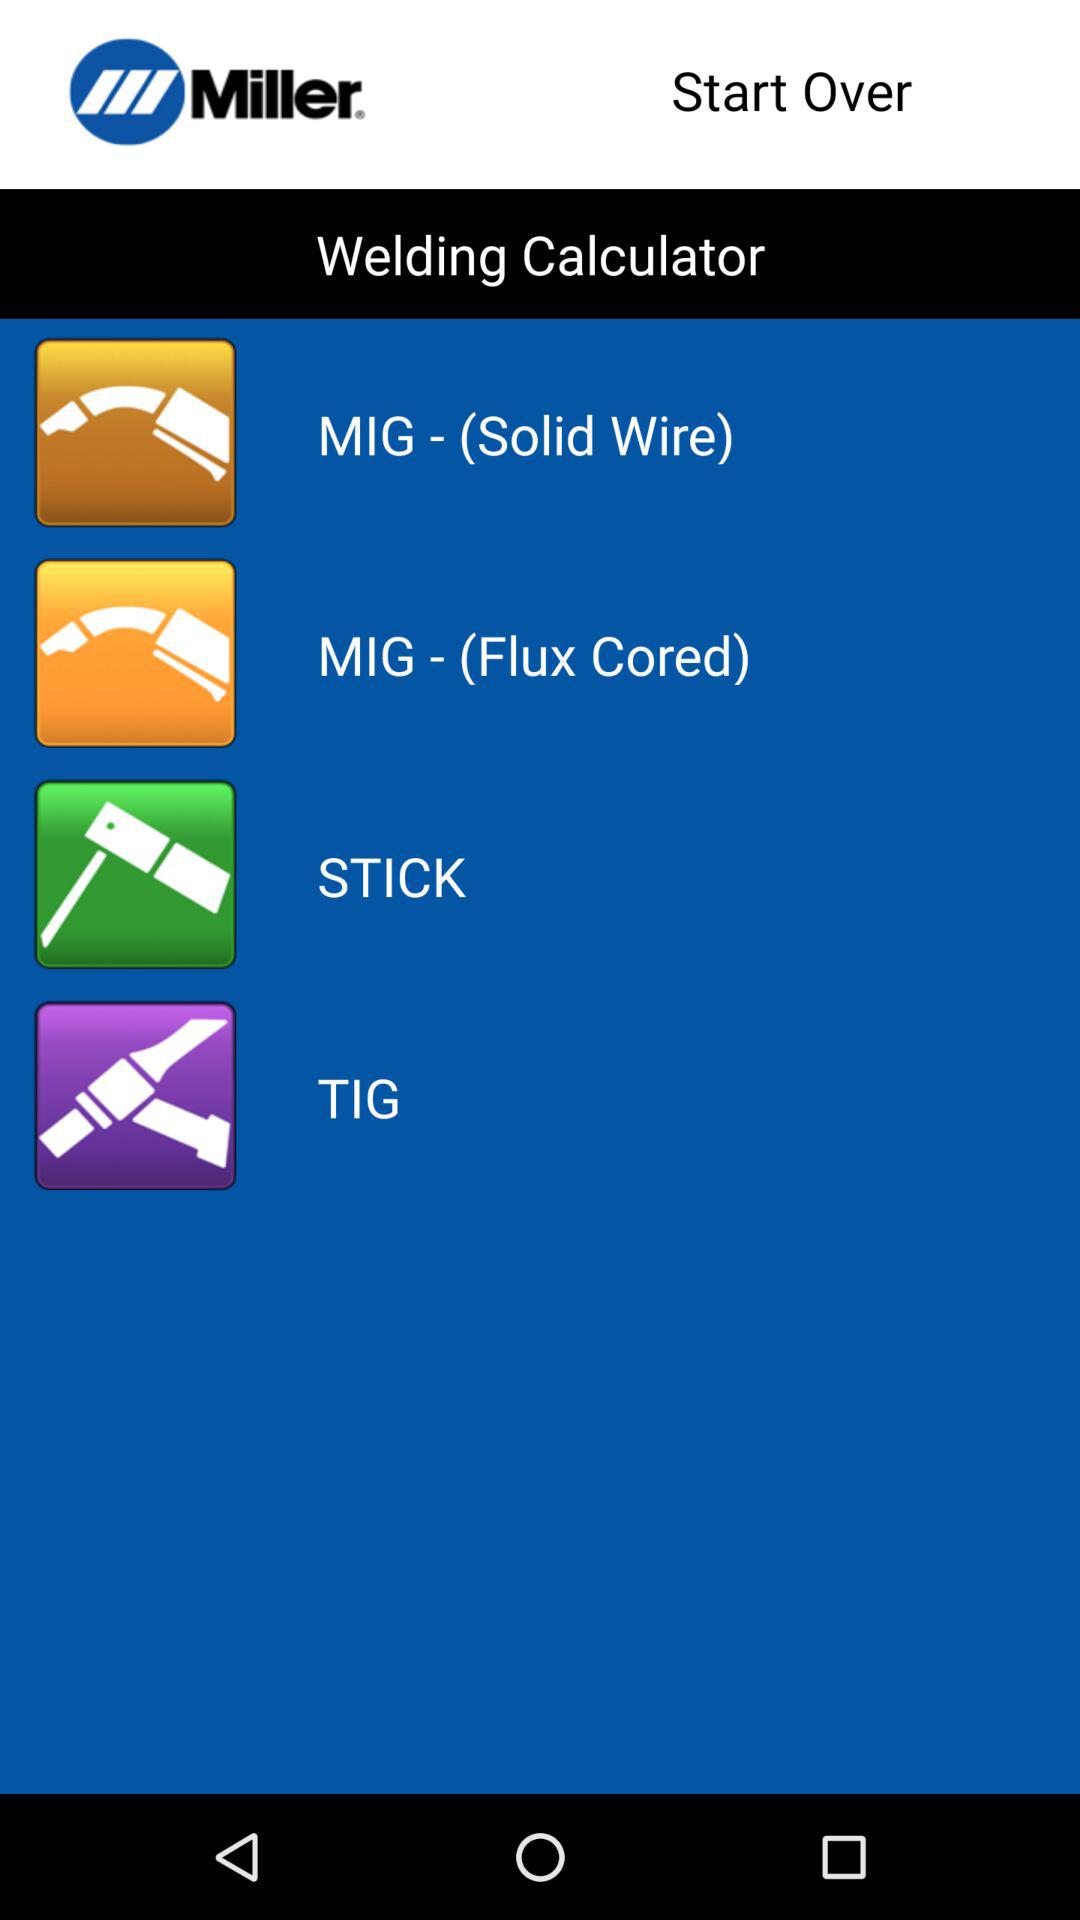What is the app name? The app name is "Miller". 